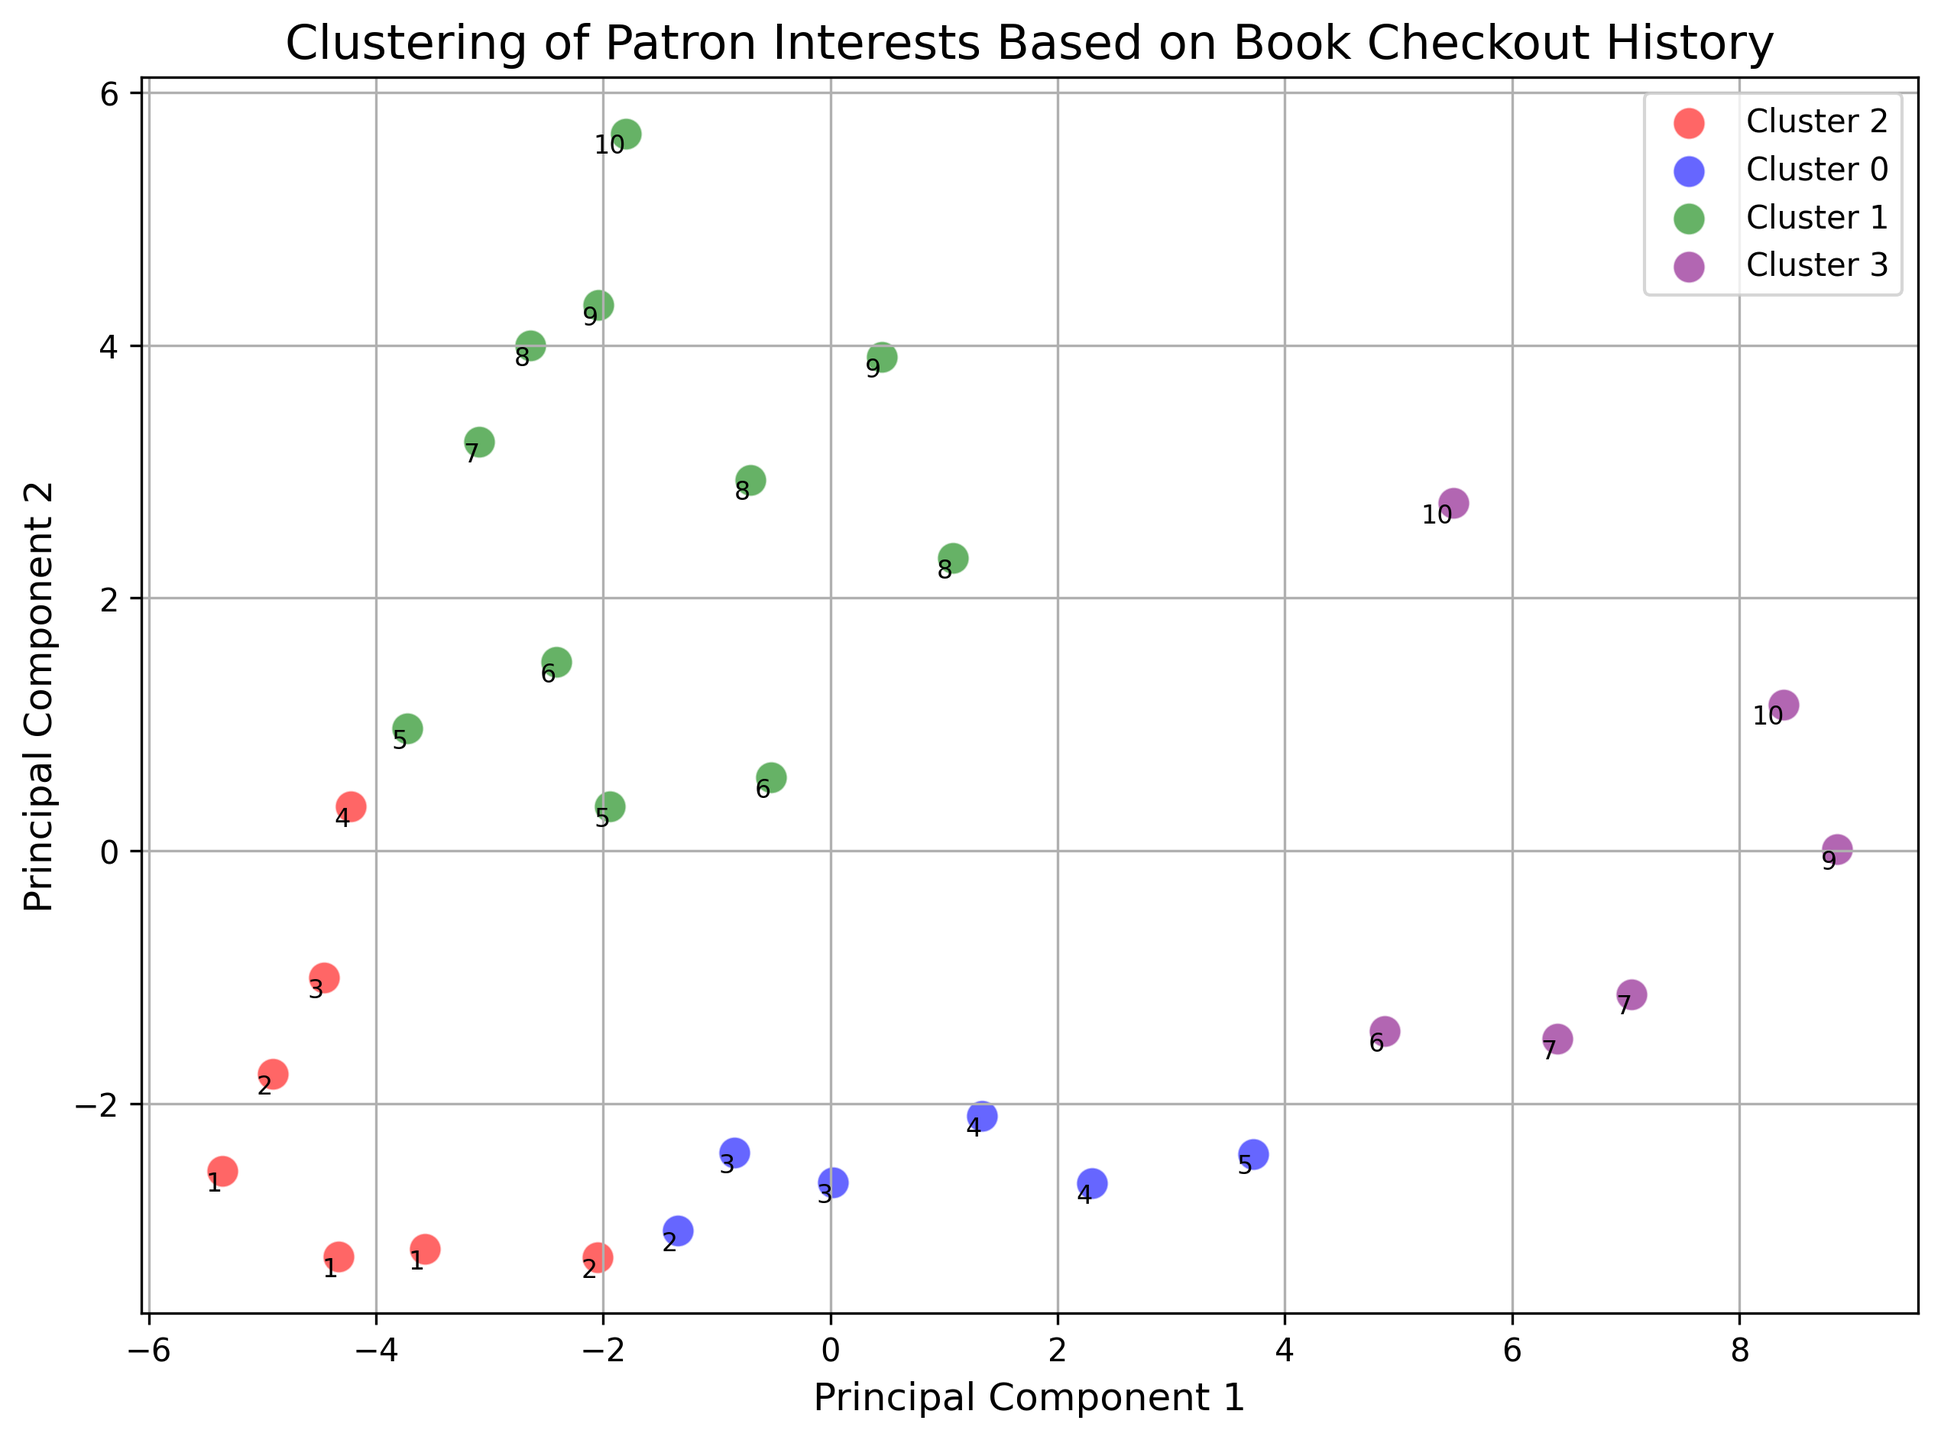What colors represent each of the clusters in the plot? The plot uses unique colors for each of the four clusters. Cluster 0 is represented in blue, Cluster 1 in green, Cluster 2 in red, and Cluster 3 in purple.
Answer: blue, green, red, purple Which cluster has the most patrons? By counting the PatronIDs clustered together, it appears that Cluster 0 has the most patrons.
Answer: Cluster 0 Which cluster contains only one patron? Evaluating the number of PatronIDs in each cluster, only Cluster 1 has a single patron (PatronID 10).
Answer: Cluster 1 What is the relationship between Cluster 3 and Clusters 0 and 2 in terms of point concentration? Clusters 0 and 2 have a more dispersed set of points, whereas Cluster 3 has a higher concentration of points in a smaller area, indicating closer patron interest patterns.
Answer: Cluster 3 is more concentrated How many patrons are in Cluster 2? By counting the unique PatronIDs in Cluster 2, there are six patrons (PatronIDs 2, 3, 5, 6, 7, 9).
Answer: 6 Does Cluster 3 contain any patron with a CheckoutCount of more than 4? Observing the data and the plotting, we see that color for Cluster 3 is only centered on patrons with relatively lower checkout counts. Thus, none have a high checkout count like 4 or more.
Answer: No Is there any cluster that can be considered an outlier in terms of patron distribution, and why? Cluster 1, represented as green, only contains PatronID 10, which indicates it has a unique distribution in comparison to other clusters with multiple patrons.
Answer: Cluster 1 Which patrons are part of Cluster 2? From the visual, Cluster 2 is identified with red: the patrons clustered are 2, 3, 5, 6, 7, 9.
Answer: 2, 3, 5, 6, 7, 9 What can be inferred about the variation in PatronID distribution within Cluster 3? Cluster 3 (purple) has closer groups and fewer patrons, reflected by the tight clustering of patron points.
Answer: Less variation 